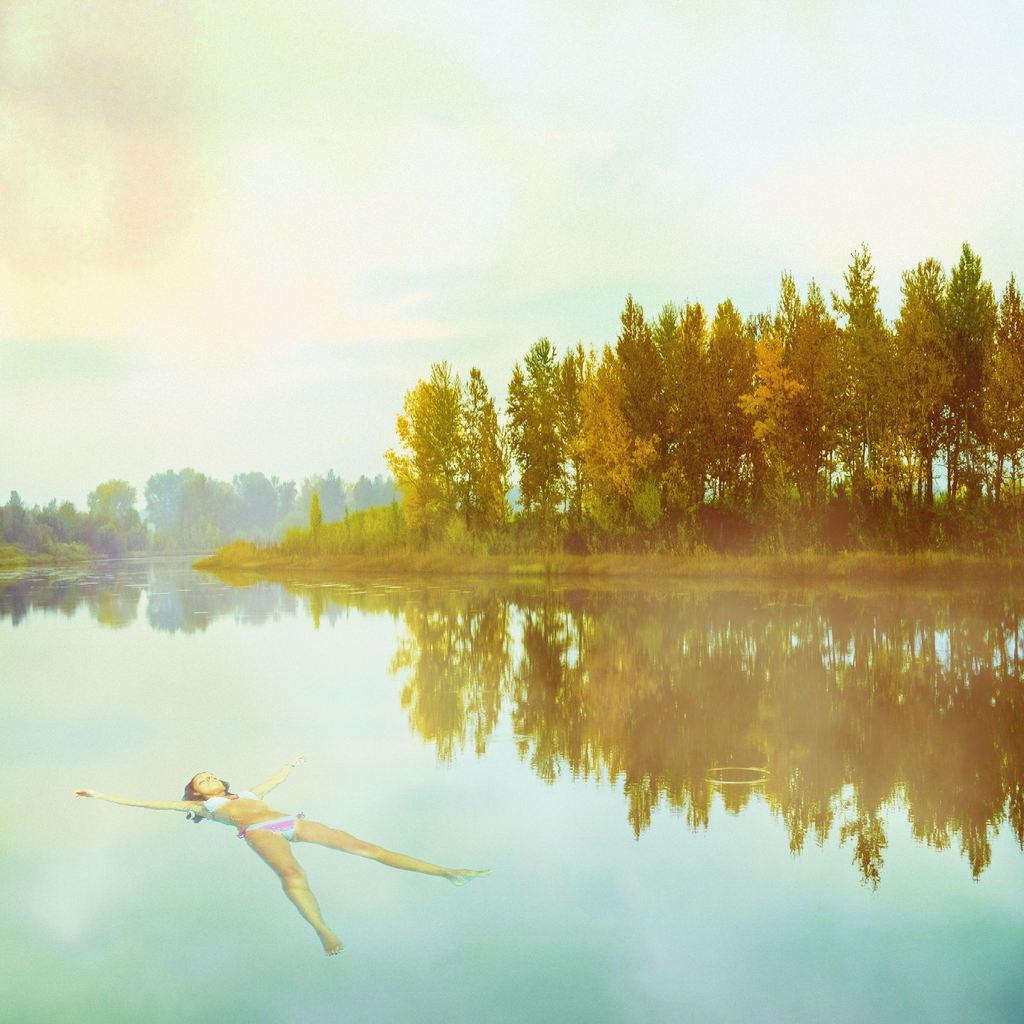How would you summarize this image in a sentence or two? In this picture i can see a woman in the water. In the background i can see trees and sky. 